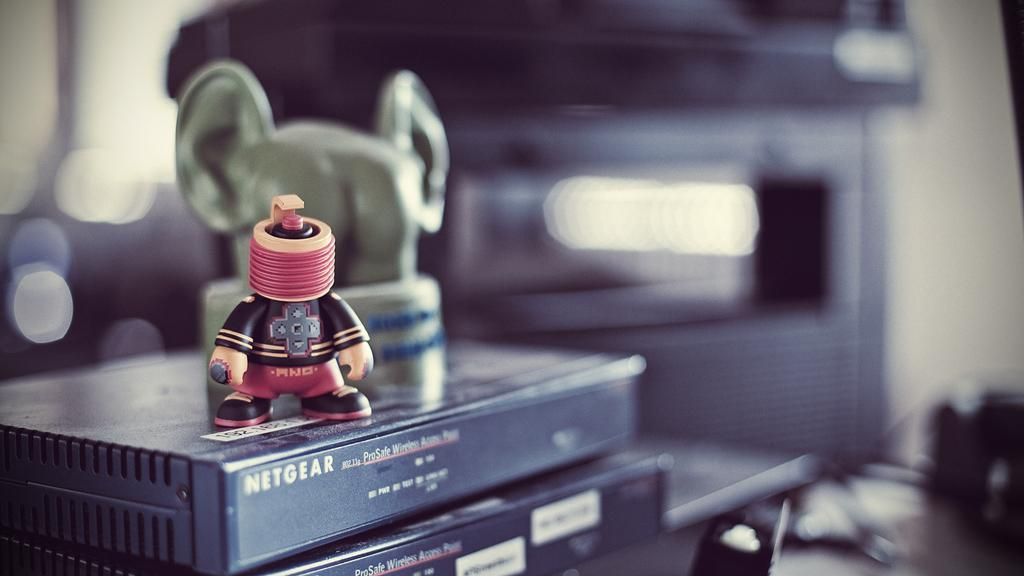Provide a one-sentence caption for the provided image. A toy figure sits on a Netgear black electronic box. 